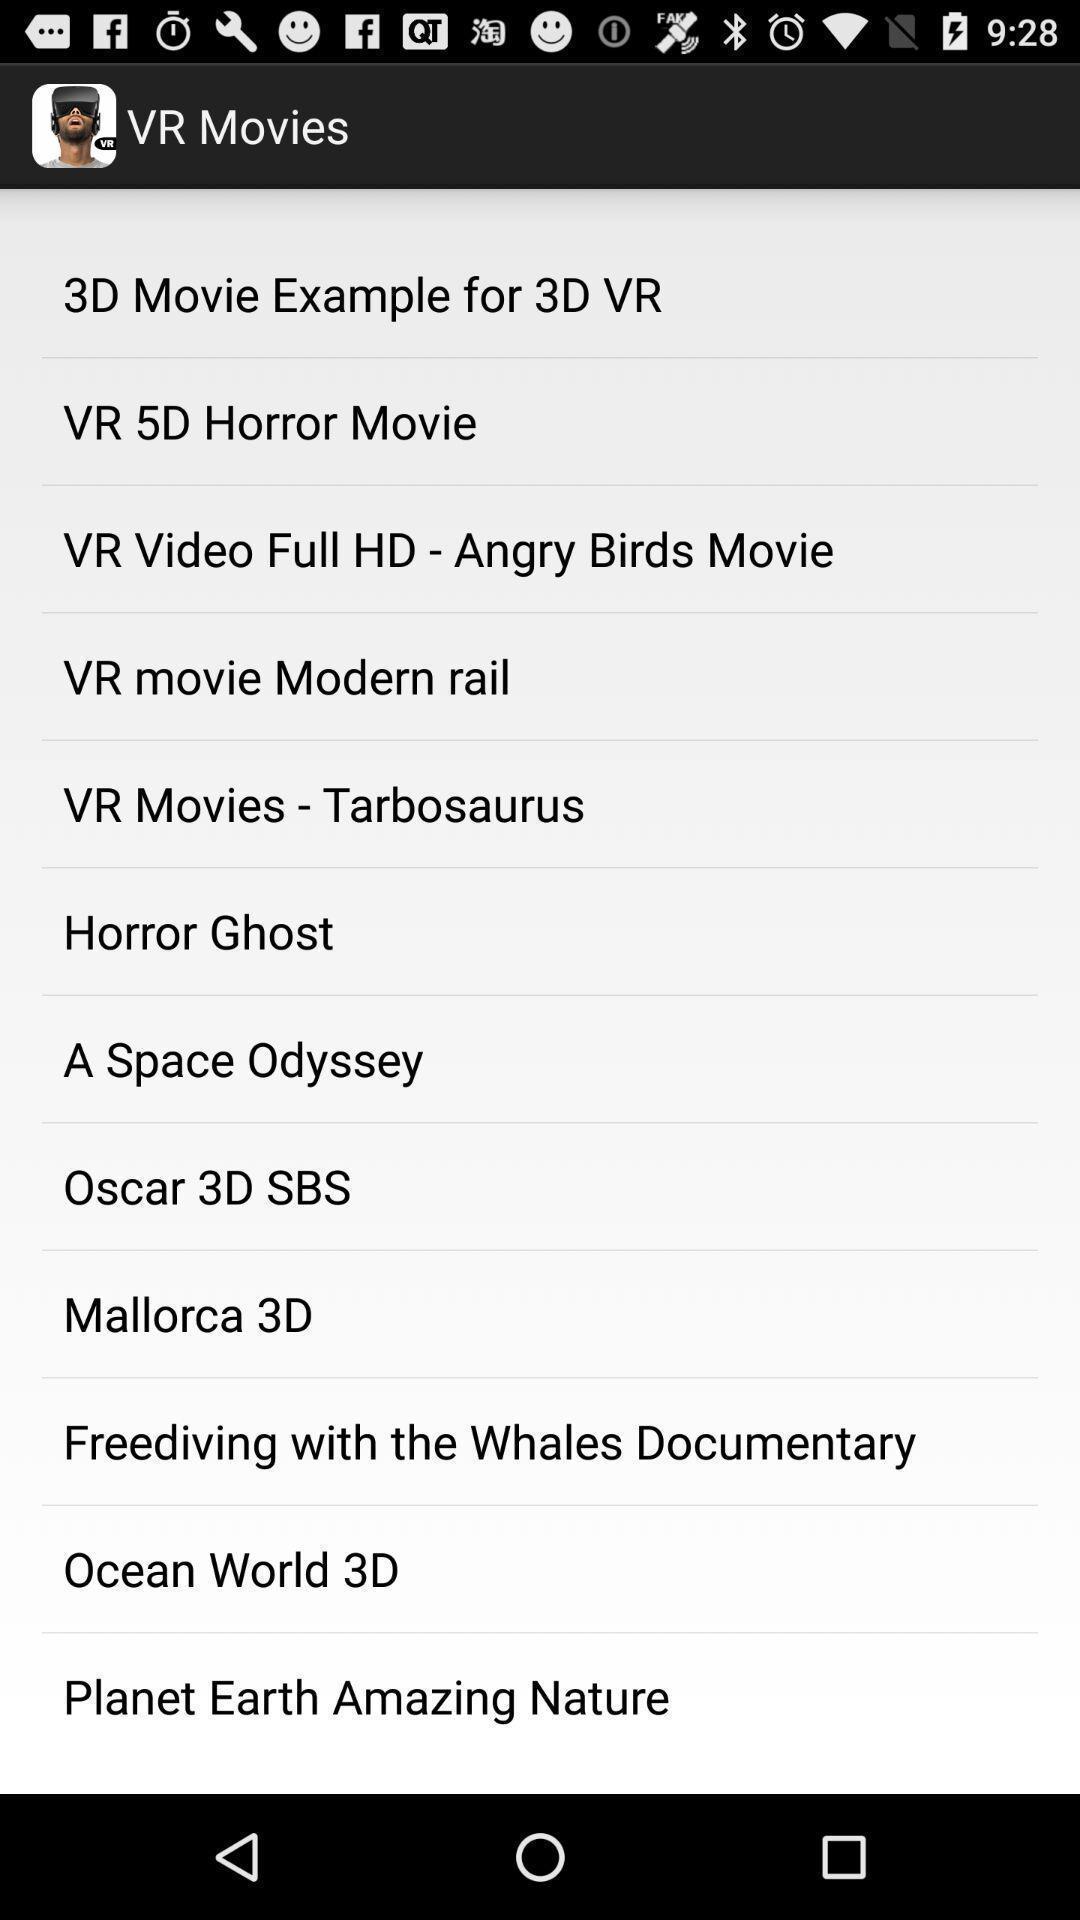What can you discern from this picture? Page displaying vr movies options. 